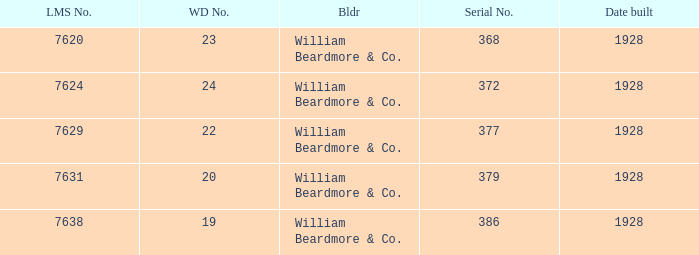Name the lms number for serial number being 372 7624.0. 